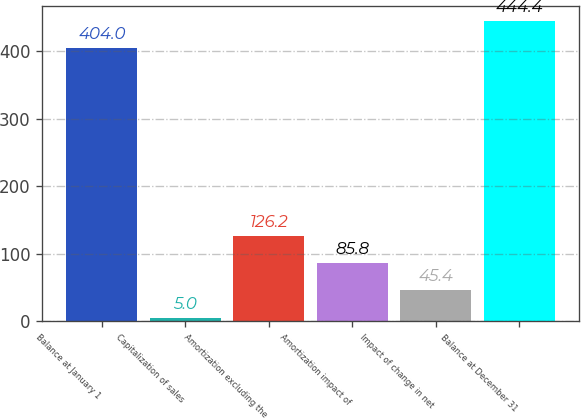Convert chart to OTSL. <chart><loc_0><loc_0><loc_500><loc_500><bar_chart><fcel>Balance at January 1<fcel>Capitalization of sales<fcel>Amortization excluding the<fcel>Amortization impact of<fcel>Impact of change in net<fcel>Balance at December 31<nl><fcel>404<fcel>5<fcel>126.2<fcel>85.8<fcel>45.4<fcel>444.4<nl></chart> 